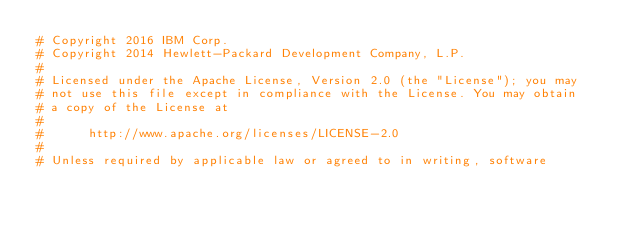<code> <loc_0><loc_0><loc_500><loc_500><_Python_># Copyright 2016 IBM Corp.
# Copyright 2014 Hewlett-Packard Development Company, L.P.
#
# Licensed under the Apache License, Version 2.0 (the "License"); you may
# not use this file except in compliance with the License. You may obtain
# a copy of the License at
#
#      http://www.apache.org/licenses/LICENSE-2.0
#
# Unless required by applicable law or agreed to in writing, software</code> 